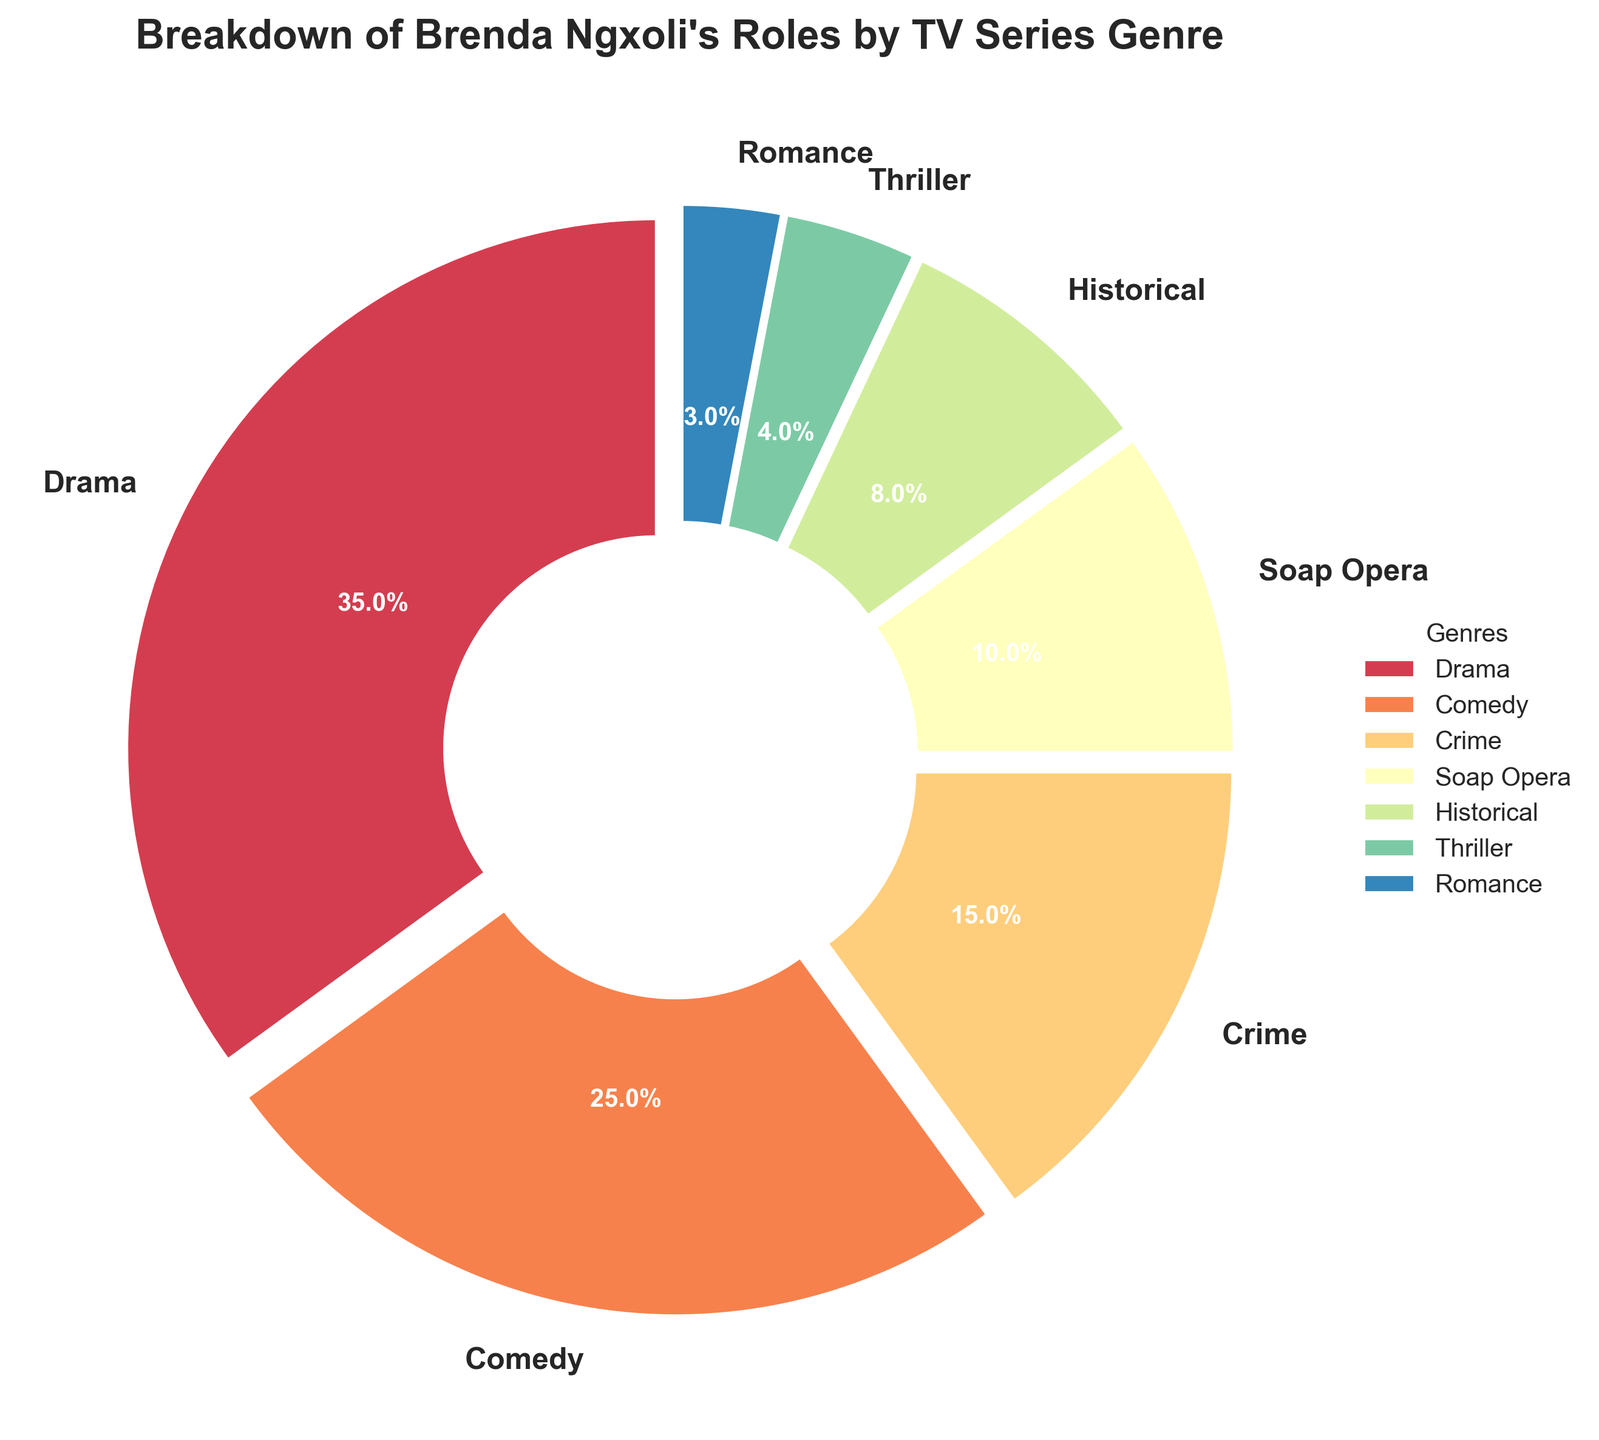What percentage of Brenda Ngxoli's roles are in Drama and Soap Opera combined? Drama roles account for 35% and Soap Opera roles account for 10%. Therefore, combined it is 35% + 10% = 45%.
Answer: 45% Which genre has a higher percentage of roles, Comedy or Crime? Comedy roles are 25%, while Crime roles are 15%. Since 25% is greater than 15%, Comedy has a higher percentage.
Answer: Comedy What is the percentage difference between Brenda Ngxoli's roles in Historical and Romance genres? Historical roles account for 8% and Romance roles account for 3%. The percentage difference is 8% - 3% = 5%.
Answer: 5% Which genre has the smallest percentage of Brenda Ngxoli's roles? The genre with the smallest percentage is Romance, at 3%.
Answer: Romance How many genres have a percentage of Brenda Ngxoli's roles that is greater than 10%? Drama (35%), Comedy (25%), and Crime (15%) all have percentages greater than 10%. Thus, there are 3 genres.
Answer: 3 If we combine the percentages of Crime, Historical, Thriller, and Romance, what is their total contribution to Brenda Ngxoli's roles? Crime (15%), Historical (8%), Thriller (4%), and Romance (3%) sum up to 15% + 8% + 4% + 3% = 30%.
Answer: 30% Which genre section appears the largest and what is its percentage? The genre section that appears the largest is Drama, with a percentage of 35%.
Answer: Drama What is the color of the Comedy genre wedge in the pie chart? The Comedy genre wedge is colored in a hue from the Spectral colormap that appears in a light pink shade.
Answer: light pink What is the mean percentage of roles across all the genres? Summing up all the percentages: 35% + 25% + 15% + 10% + 8% + 4% + 3% = 100%. There are 7 genres, so the mean is 100% / 7 ≈ 14.3%.
Answer: 14.3% Which genre has a higher percentage of roles, Historical or Soap Opera? Soap Opera roles are 10%, while Historical roles are 8%. Thus, Soap Opera has a higher percentage.
Answer: Soap Opera 